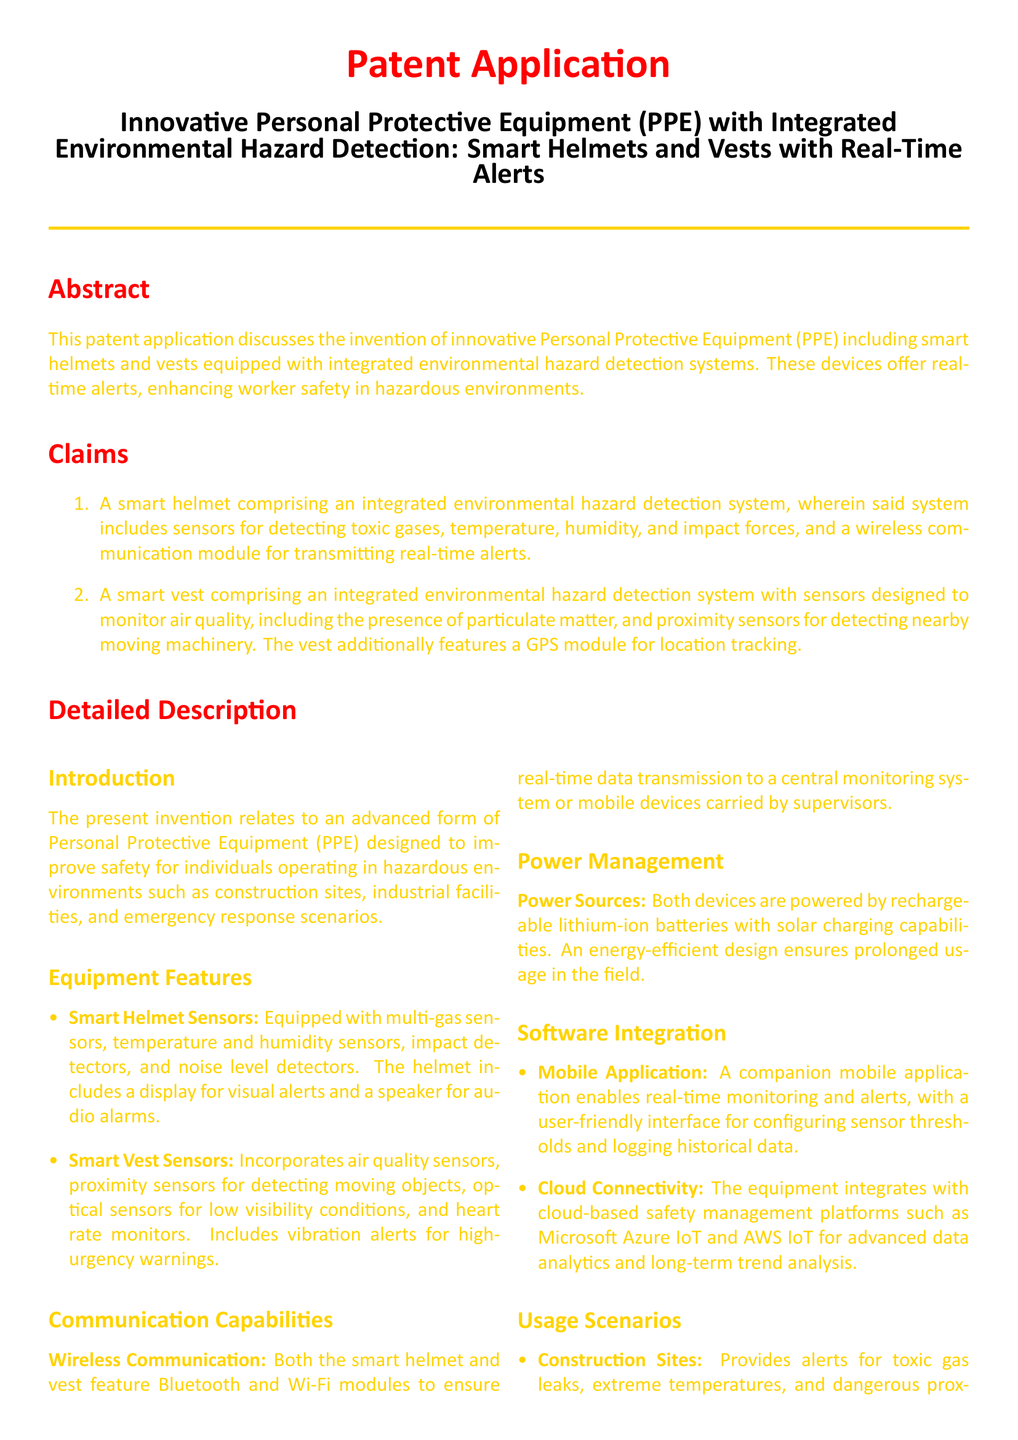what types of sensors does the smart helmet have? The document lists multi-gas sensors, temperature and humidity sensors, impact detectors, and noise level detectors as part of the smart helmet features.
Answer: multi-gas, temperature, humidity, impact, noise what does the smart vest monitor? The document states that the smart vest monitors air quality, including the presence of particulate matter and detects nearby moving machinery.
Answer: air quality, particulate matter, moving machinery which organization’s regulations does the equipment help maintain compliance with? The document mentions that the equipment helps maintain compliance with regulations set by OSHA and ANSI.
Answer: OSHA, ANSI what is a power source for the smart helmet and vest? The document indicates that both devices are powered by rechargeable lithium-ion batteries with solar charging capabilities.
Answer: rechargeable lithium-ion batteries how many claims are made in the patent application? The total number of claims is explicitly mentioned in the claims section of the document.
Answer: two what feature enhances real-time alerts for the smart vest? The document specifies that the smart vest includes vibration alerts for high-urgency warnings to enhance real-time alerts.
Answer: vibration alerts what application is mentioned for mobile devices? The document describes a companion mobile application that enables real-time monitoring and alerts.
Answer: mobile application in which environments is this PPE intended to be used? The document states that the PPE is designed for hazardous environments such as construction sites, industrial facilities, and emergency response scenarios.
Answer: construction sites, industrial facilities, emergency response 